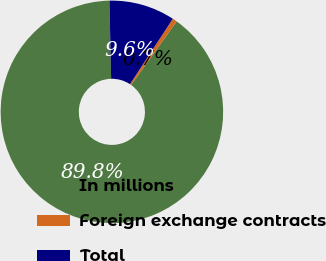Convert chart to OTSL. <chart><loc_0><loc_0><loc_500><loc_500><pie_chart><fcel>In millions<fcel>Foreign exchange contracts<fcel>Total<nl><fcel>89.76%<fcel>0.67%<fcel>9.58%<nl></chart> 